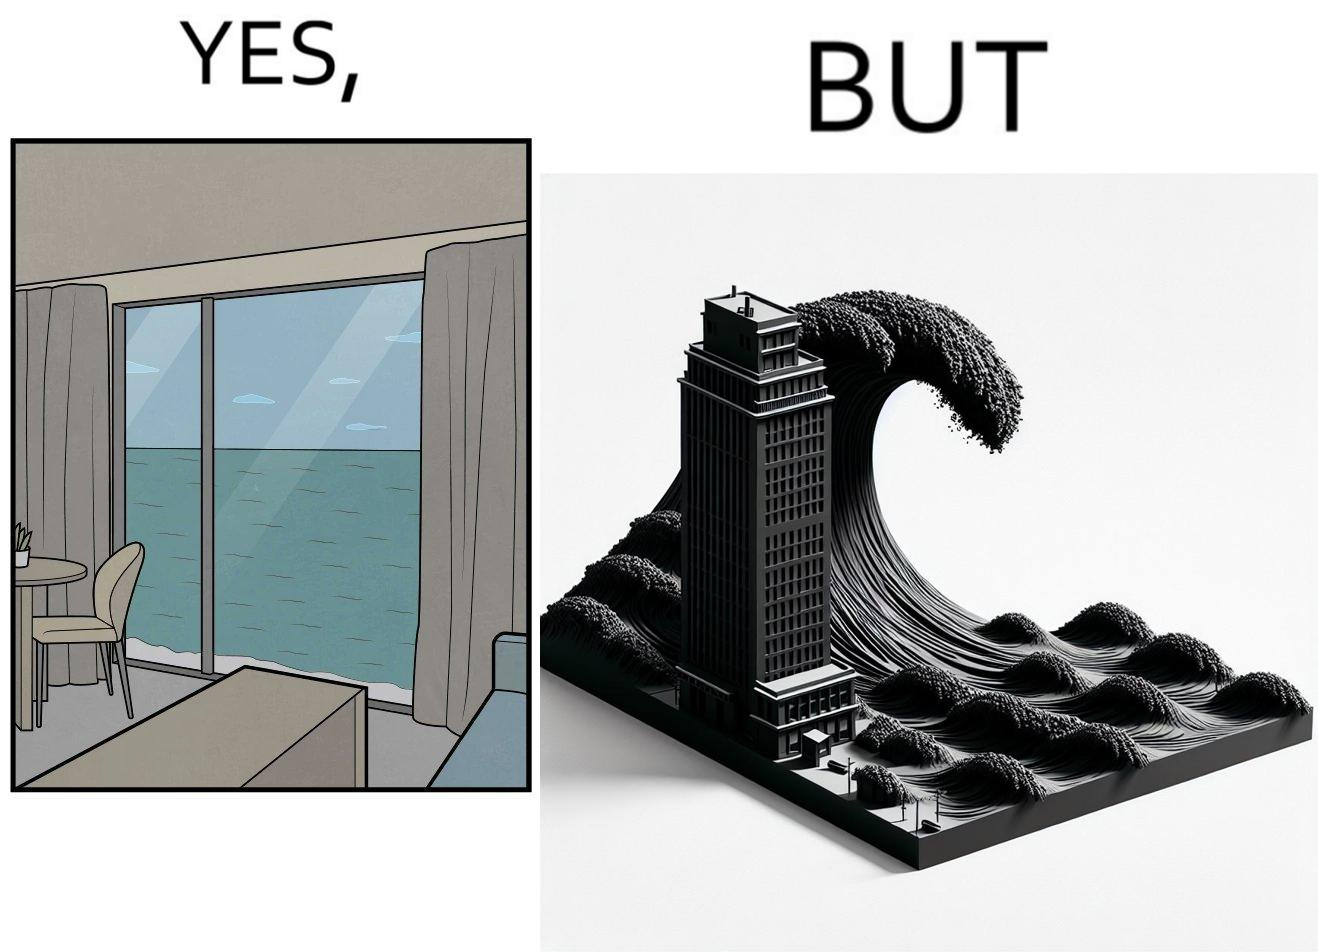Is this image satirical or non-satirical? Yes, this image is satirical. 